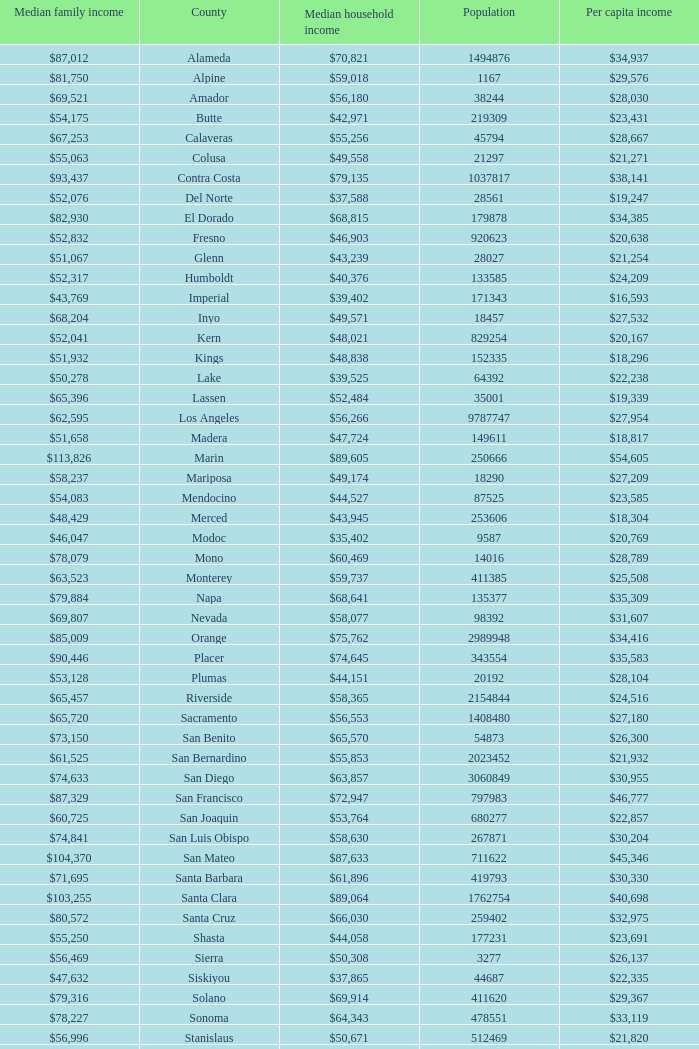Name the median family income for riverside $65,457. 